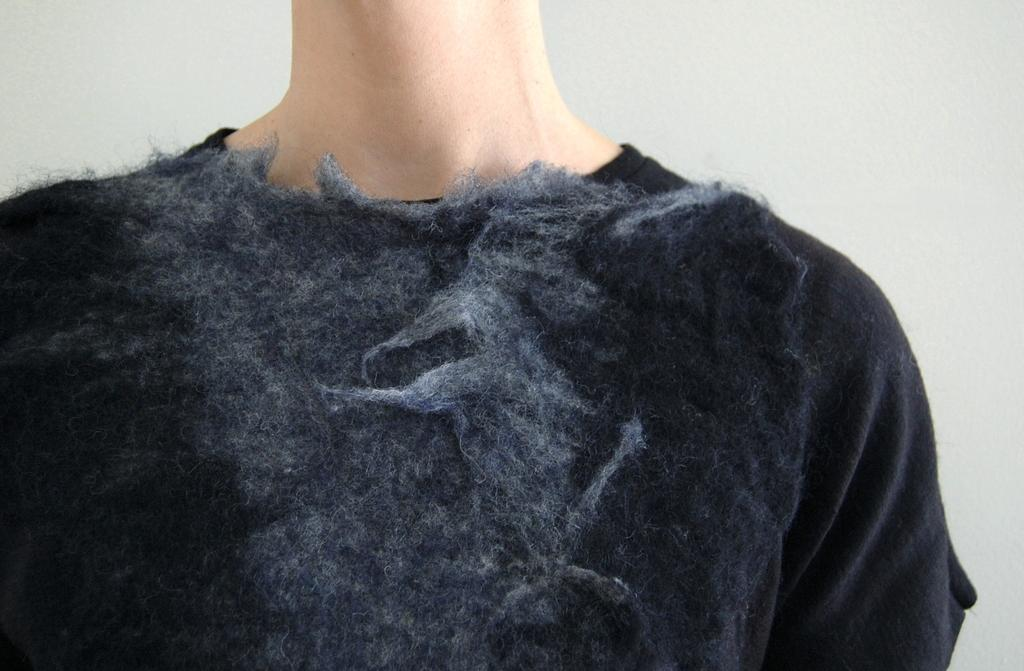Who or what is present in the image? There is a person in the image. What is the person wearing? The person is wearing a black T-shirt. How much of the person is visible in the image? The person is partially covered. What can be seen in the background of the image? There is a wall visible in the image. What type of quill is the person holding in the image? There is no quill present in the image. What kind of cloth is draped over the person in the image? The person is partially covered, but there is no specific cloth mentioned in the provided facts. 